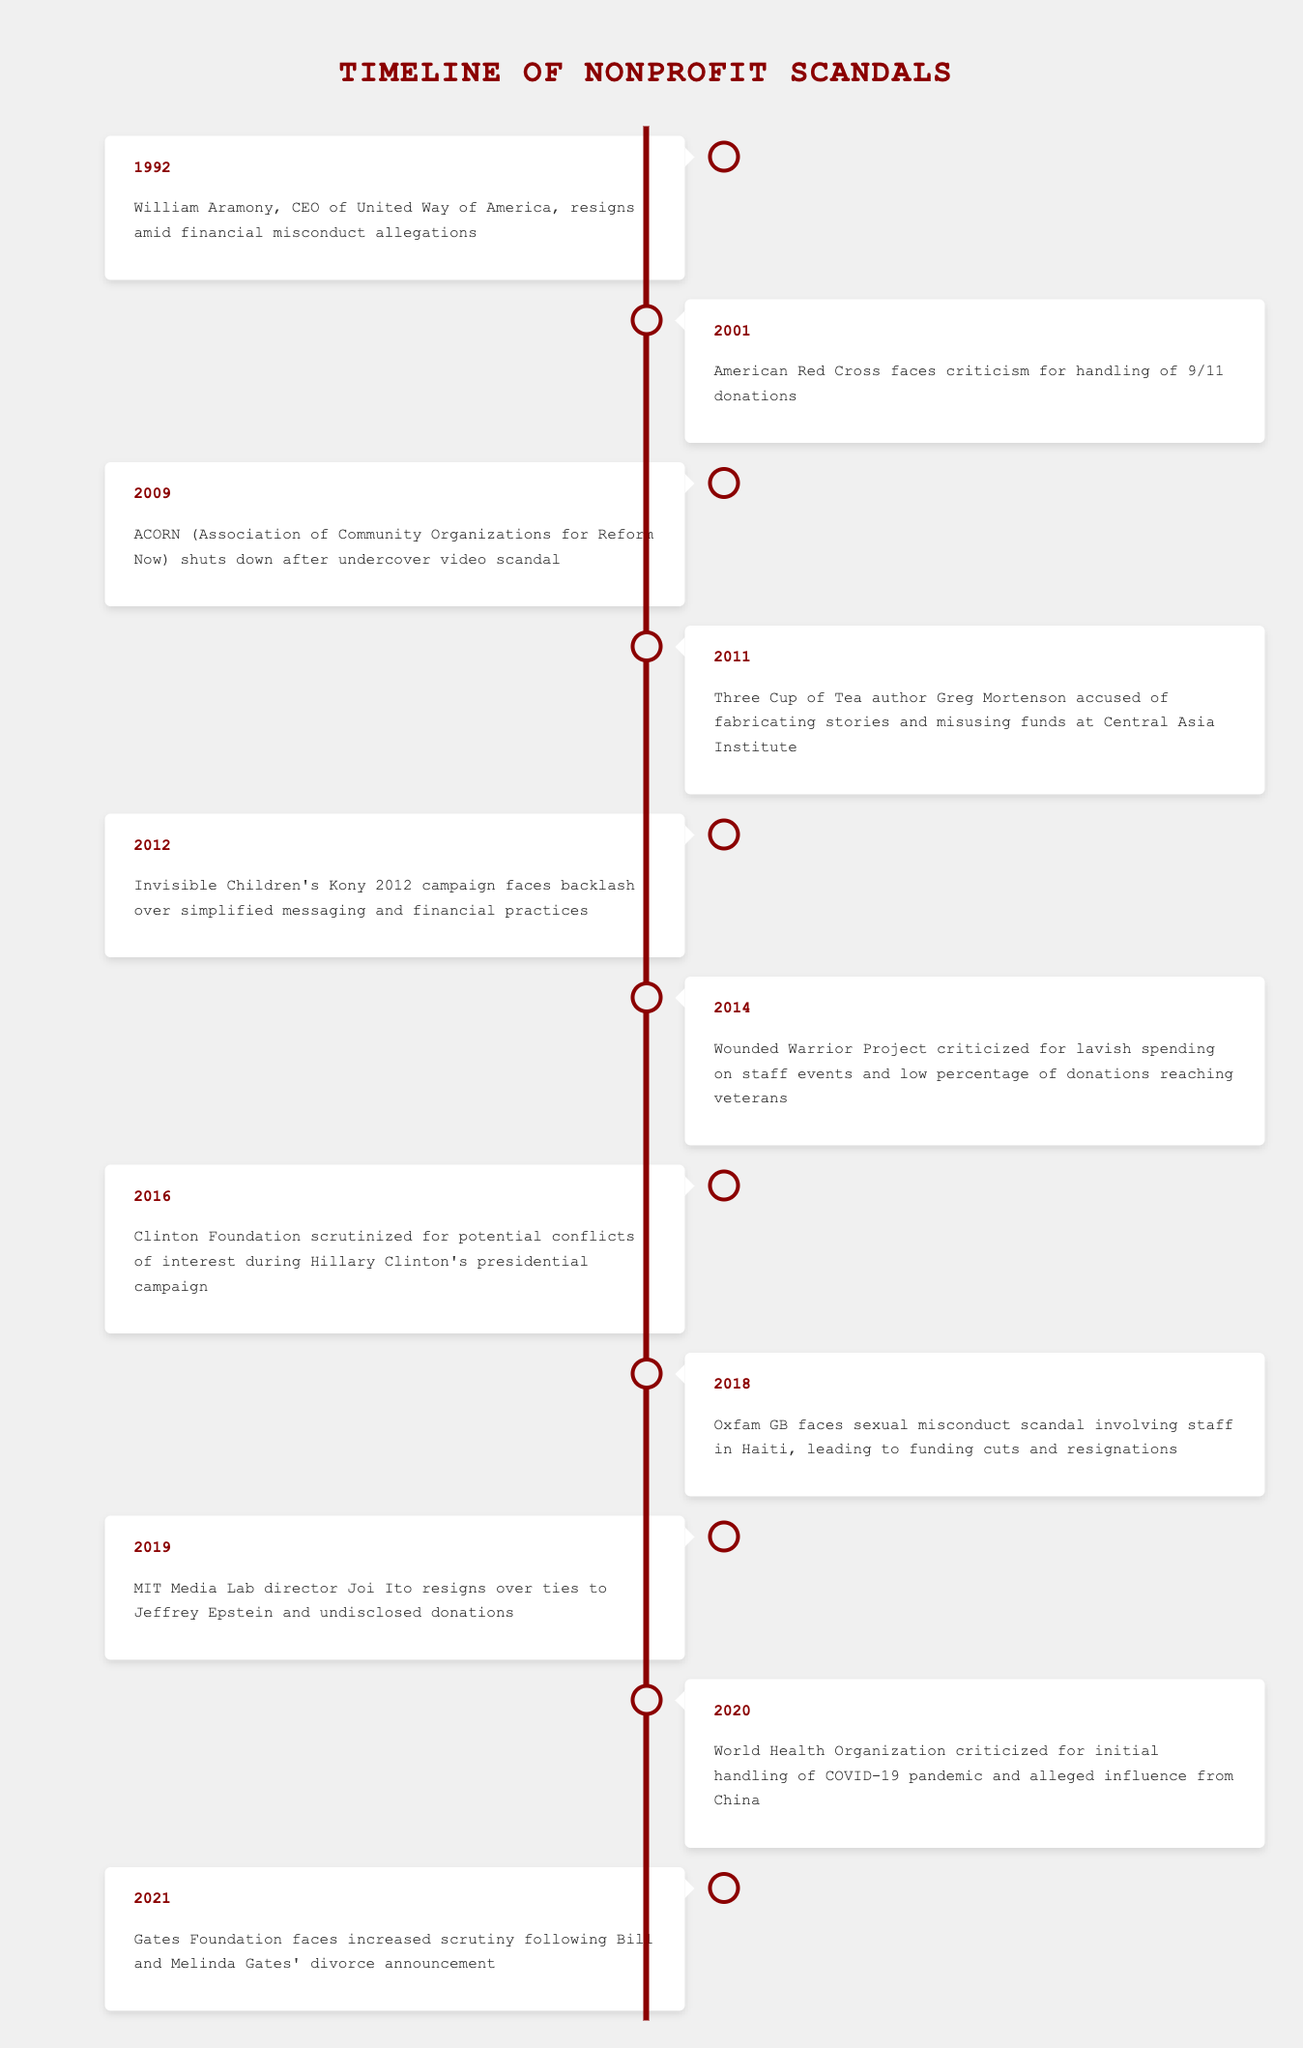What event occurred in 2001? The table indicates that in 2001, the American Red Cross faced criticism for its handling of 9/11 donations.
Answer: American Red Cross faces criticism for handling of 9/11 donations How many events are listed between 1992 and 2010? By counting the rows for the years 1992 to 2010, we see there are 4 events: 1992, 2001, 2009, and 2010.
Answer: 4 Did the Wounded Warrior Project scandal occur after the Kony 2012 campaign? The Wounded Warrior Project scandal is listed in 2014, while the Kony 2012 campaign is from 2012, making it a yes.
Answer: Yes Which scandal involves the Clinton Foundation? The 2016 event in the table notes the Clinton Foundation was scrutinized for potential conflicts of interest during Hillary Clinton’s presidential campaign.
Answer: Clinton Foundation scrutinized for potential conflicts of interest during Hillary Clinton's presidential campaign What is the year with the most recent event listed? Looking at the years in the table, 2021 is the most recent year mentioned with the Gates Foundation scandal.
Answer: 2021 How many years are covered in the timeline? The earliest event is in 1992 and the latest in 2021, giving a span of 30 years (2021 - 1992 = 29, but since it's inclusive of both ends, add 1).
Answer: 30 Was there a scandal related to sexual misconduct listed in the table? Referring to the 2018 event, Oxfam GB faces a scandal involving sexual misconduct in Haiti. Hence, the answer is yes.
Answer: Yes What two events are associated with financial misuse or mismanagement? The years 1992 (William Aramony) and 2011 (Greg Mortenson) both relate to allegations of financial misconduct or misuse.
Answer: William Aramony resignation and Greg Mortenson accusations In what years did incidents related to high-profile nonprofit scandals occur during a significant national event? The years 2001 (9/11) and 2020 (COVID-19 pandemic) are associated with significant national events coinciding with nonprofit scandals.
Answer: 2001 and 2020 